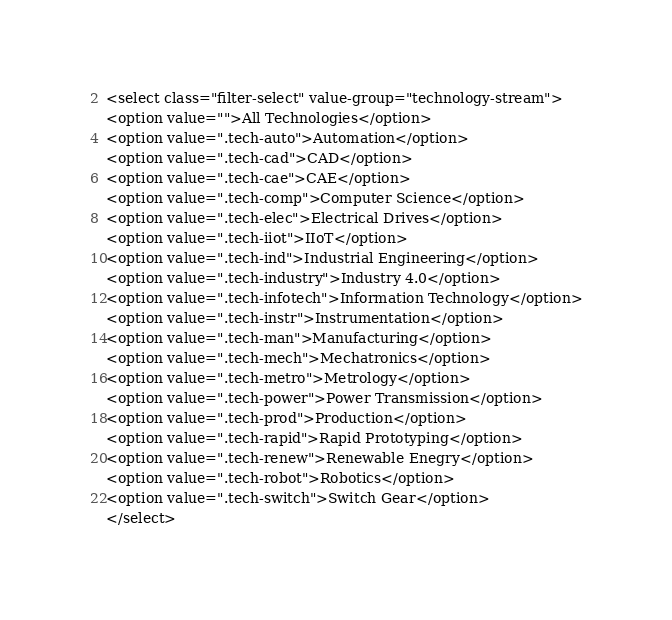Convert code to text. <code><loc_0><loc_0><loc_500><loc_500><_PHP_><select class="filter-select" value-group="technology-stream">
<option value="">All Technologies</option>
<option value=".tech-auto">Automation</option>
<option value=".tech-cad">CAD</option>
<option value=".tech-cae">CAE</option>
<option value=".tech-comp">Computer Science</option>
<option value=".tech-elec">Electrical Drives</option>
<option value=".tech-iiot">IIoT</option>
<option value=".tech-ind">Industrial Engineering</option>
<option value=".tech-industry">Industry 4.0</option>
<option value=".tech-infotech">Information Technology</option>
<option value=".tech-instr">Instrumentation</option>
<option value=".tech-man">Manufacturing</option>
<option value=".tech-mech">Mechatronics</option>
<option value=".tech-metro">Metrology</option>
<option value=".tech-power">Power Transmission</option>
<option value=".tech-prod">Production</option>
<option value=".tech-rapid">Rapid Prototyping</option>
<option value=".tech-renew">Renewable Enegry</option>
<option value=".tech-robot">Robotics</option>
<option value=".tech-switch">Switch Gear</option>
</select></code> 